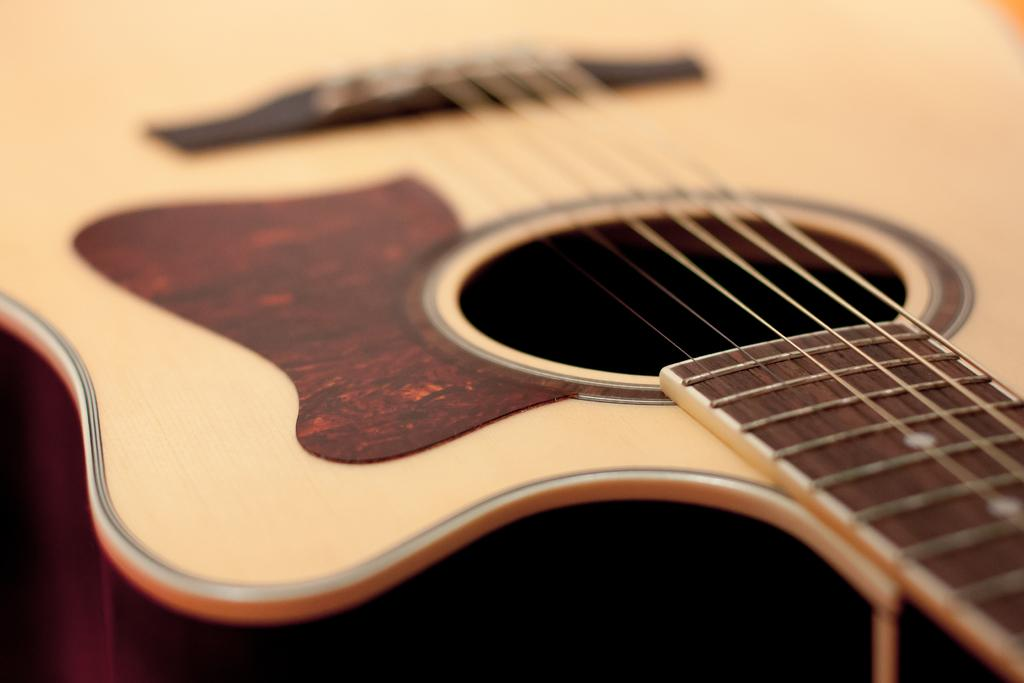What musical instrument is present in the image? There is a guitar in the image. What is the color of the guitar? The guitar is wooden in color. How is the guitar described in the image? The guitar is described as beautiful. What decision does the guitar make in the image? The guitar does not make decisions in the image, as it is an inanimate object. 